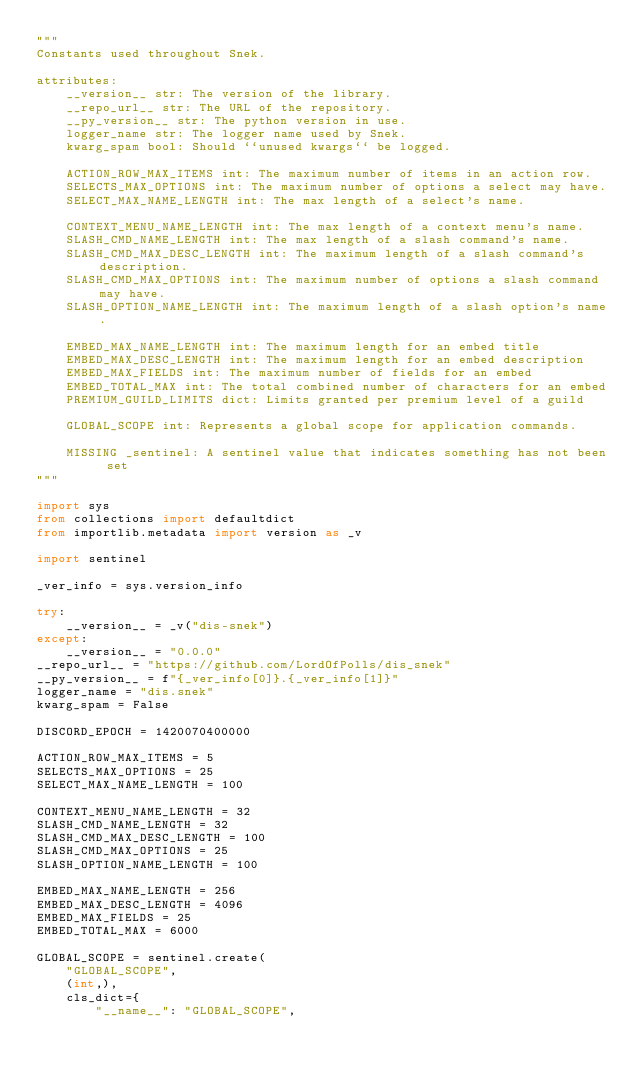<code> <loc_0><loc_0><loc_500><loc_500><_Python_>"""
Constants used throughout Snek.

attributes:
    __version__ str: The version of the library.
    __repo_url__ str: The URL of the repository.
    __py_version__ str: The python version in use.
    logger_name str: The logger name used by Snek.
    kwarg_spam bool: Should ``unused kwargs`` be logged.

    ACTION_ROW_MAX_ITEMS int: The maximum number of items in an action row.
    SELECTS_MAX_OPTIONS int: The maximum number of options a select may have.
    SELECT_MAX_NAME_LENGTH int: The max length of a select's name.

    CONTEXT_MENU_NAME_LENGTH int: The max length of a context menu's name.
    SLASH_CMD_NAME_LENGTH int: The max length of a slash command's name.
    SLASH_CMD_MAX_DESC_LENGTH int: The maximum length of a slash command's description.
    SLASH_CMD_MAX_OPTIONS int: The maximum number of options a slash command may have.
    SLASH_OPTION_NAME_LENGTH int: The maximum length of a slash option's name.

    EMBED_MAX_NAME_LENGTH int: The maximum length for an embed title
    EMBED_MAX_DESC_LENGTH int: The maximum length for an embed description
    EMBED_MAX_FIELDS int: The maximum number of fields for an embed
    EMBED_TOTAL_MAX int: The total combined number of characters for an embed
    PREMIUM_GUILD_LIMITS dict: Limits granted per premium level of a guild

    GLOBAL_SCOPE int: Represents a global scope for application commands.

    MISSING _sentinel: A sentinel value that indicates something has not been set
"""

import sys
from collections import defaultdict
from importlib.metadata import version as _v

import sentinel

_ver_info = sys.version_info

try:
    __version__ = _v("dis-snek")
except:
    __version__ = "0.0.0"
__repo_url__ = "https://github.com/LordOfPolls/dis_snek"
__py_version__ = f"{_ver_info[0]}.{_ver_info[1]}"
logger_name = "dis.snek"
kwarg_spam = False

DISCORD_EPOCH = 1420070400000

ACTION_ROW_MAX_ITEMS = 5
SELECTS_MAX_OPTIONS = 25
SELECT_MAX_NAME_LENGTH = 100

CONTEXT_MENU_NAME_LENGTH = 32
SLASH_CMD_NAME_LENGTH = 32
SLASH_CMD_MAX_DESC_LENGTH = 100
SLASH_CMD_MAX_OPTIONS = 25
SLASH_OPTION_NAME_LENGTH = 100

EMBED_MAX_NAME_LENGTH = 256
EMBED_MAX_DESC_LENGTH = 4096
EMBED_MAX_FIELDS = 25
EMBED_TOTAL_MAX = 6000

GLOBAL_SCOPE = sentinel.create(
    "GLOBAL_SCOPE",
    (int,),
    cls_dict={
        "__name__": "GLOBAL_SCOPE",</code> 